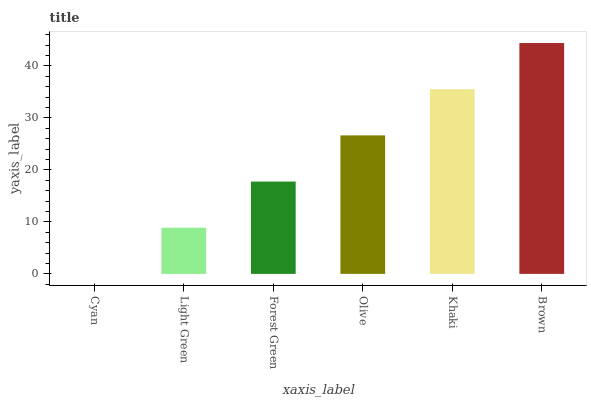Is Cyan the minimum?
Answer yes or no. Yes. Is Brown the maximum?
Answer yes or no. Yes. Is Light Green the minimum?
Answer yes or no. No. Is Light Green the maximum?
Answer yes or no. No. Is Light Green greater than Cyan?
Answer yes or no. Yes. Is Cyan less than Light Green?
Answer yes or no. Yes. Is Cyan greater than Light Green?
Answer yes or no. No. Is Light Green less than Cyan?
Answer yes or no. No. Is Olive the high median?
Answer yes or no. Yes. Is Forest Green the low median?
Answer yes or no. Yes. Is Brown the high median?
Answer yes or no. No. Is Brown the low median?
Answer yes or no. No. 